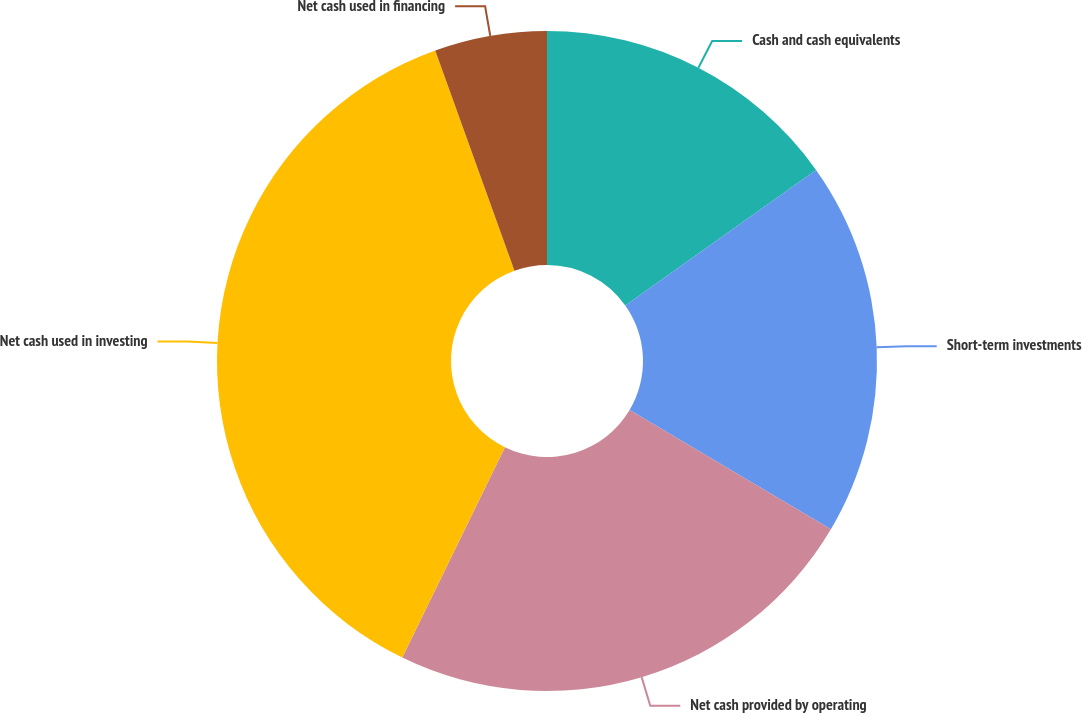Convert chart. <chart><loc_0><loc_0><loc_500><loc_500><pie_chart><fcel>Cash and cash equivalents<fcel>Short-term investments<fcel>Net cash provided by operating<fcel>Net cash used in investing<fcel>Net cash used in financing<nl><fcel>15.17%<fcel>18.34%<fcel>23.71%<fcel>37.27%<fcel>5.5%<nl></chart> 